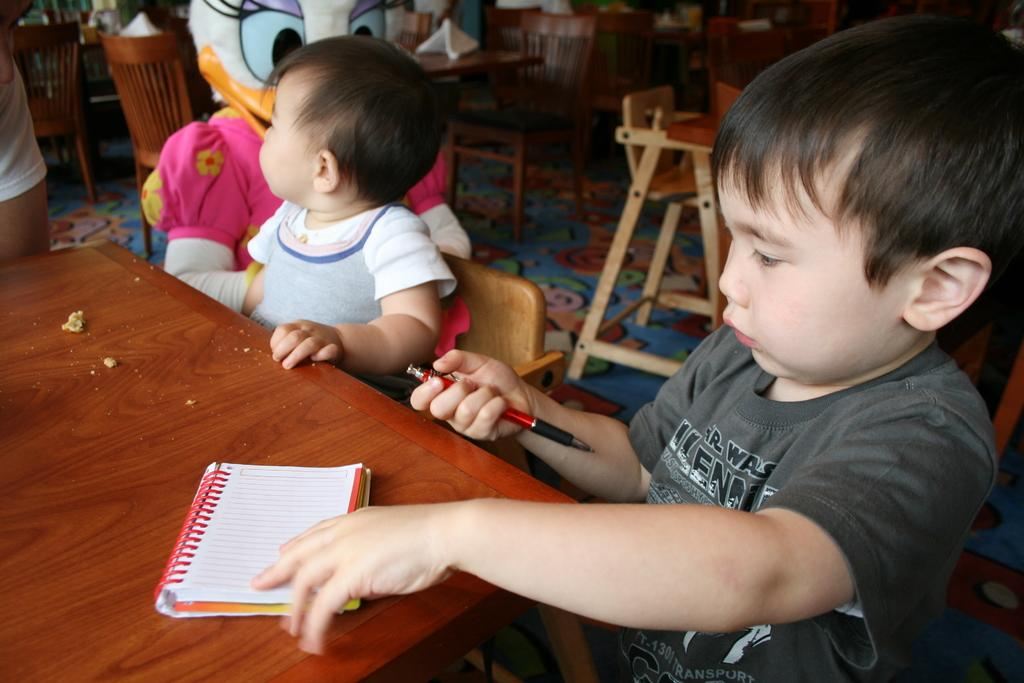How many people are in the image? There are three persons in the image. What are the persons doing in the image? The persons are sitting on chairs. What is on the table in the image? There is a paper on the table. Can you describe the boy's position in the image? The boy is on the right side of the image. What is the boy holding in the image? The boy is holding a pen. What holiday is being celebrated in the image? There is no indication of a holiday being celebrated in the image. What is the cause of the boy's excitement in the image? The image does not show the boy's emotions or any indication of excitement. 